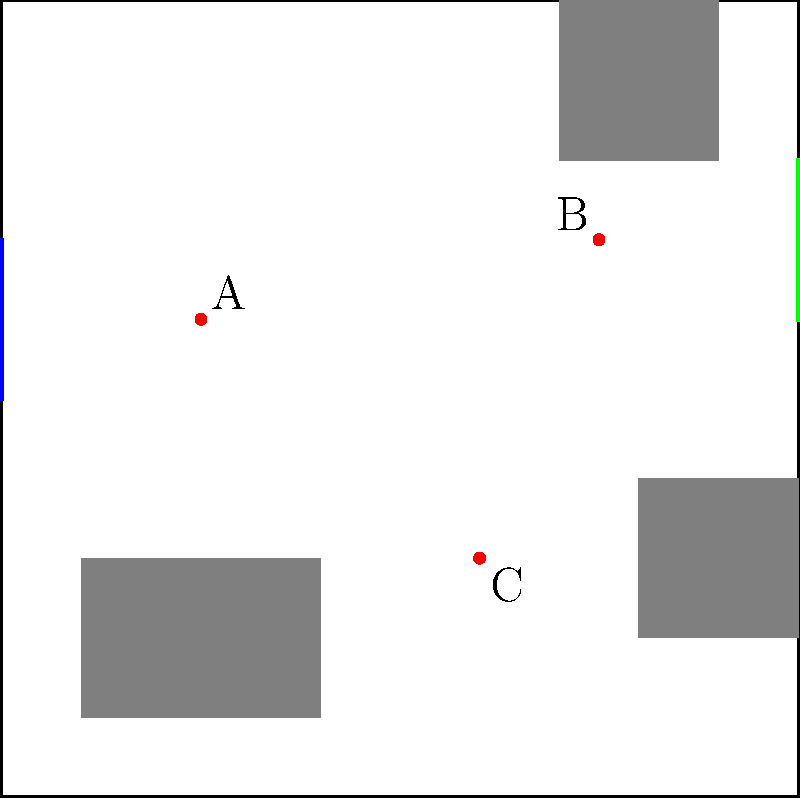Based on witness descriptions, you've reconstructed a crime scene layout. The room has one door on the left wall and one window on the right wall. Three key pieces of evidence (A, B, and C) were found. If the perpetrator entered through the door and exited through the window, which piece of evidence was most likely encountered first? To determine which piece of evidence was most likely encountered first, we need to analyze the layout and the probable path of the perpetrator:

1. The perpetrator entered through the door on the left wall.
2. The exit point was the window on the right wall.
3. The most direct path would be from the door to the window.

Let's examine the evidence markers:

A: Located near the center-left of the room.
B: Positioned in the upper-right quadrant of the room.
C: Found in the lower-right quadrant of the room.

Considering the likely path from the door to the window:

1. Evidence A is closest to the entry point (door).
2. Evidence B is close to the exit point (window).
3. Evidence C is off the direct path between the door and window.

Given this analysis, the perpetrator would most likely encounter evidence A first, as it's the closest to the entry point and on the most direct path to the exit.
Answer: A 